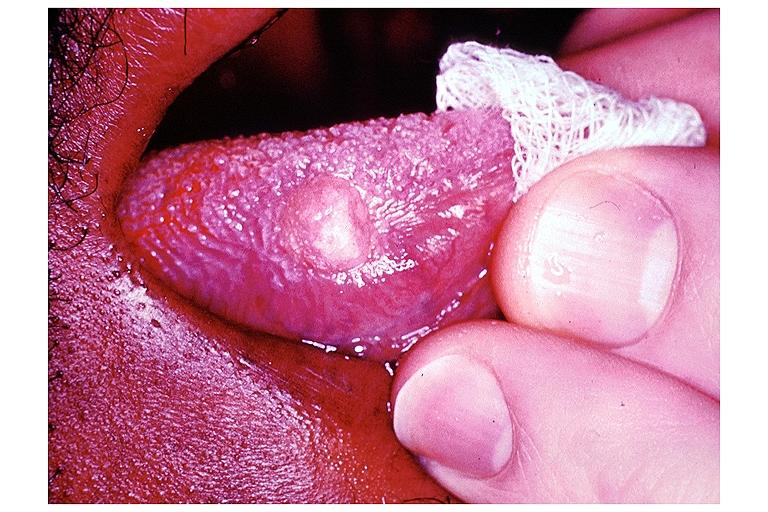where is this?
Answer the question using a single word or phrase. Oral 